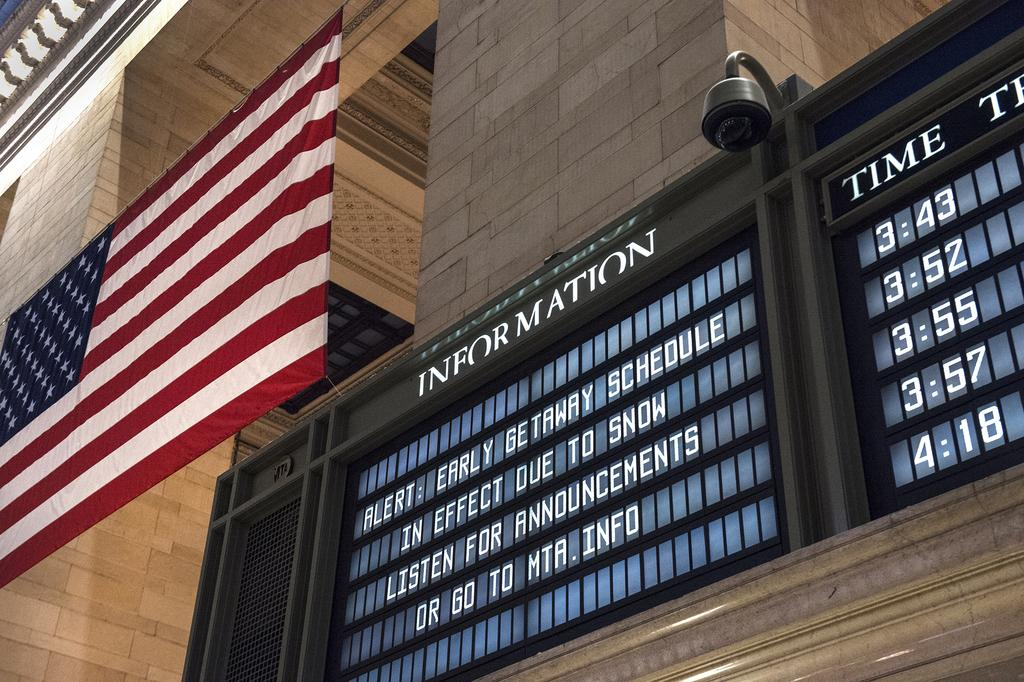What is the main structure in the center of the image? There is a building in the center of the image. What type of barrier can be seen in the image? There is a wall and a fence in the image. What is attached to the wall or fence in the image? There is a flag and a banner in the image. What is written on the banner? There is text on the banner. What type of decoration is on the wall? There is artwork on the wall. Are there any other objects or features in the image? Yes, there are other objects in the image. How many cherries are hanging from the flag in the image? There are no cherries present in the image, and therefore no such objects can be observed. What type of pet can be seen playing with the banner in the image? There is no pet present in the image; the banner is stationary and not being played with. 